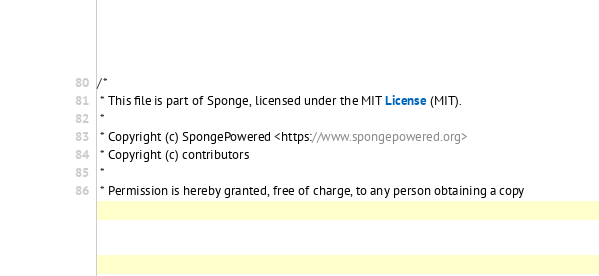<code> <loc_0><loc_0><loc_500><loc_500><_Java_>/*
 * This file is part of Sponge, licensed under the MIT License (MIT).
 *
 * Copyright (c) SpongePowered <https://www.spongepowered.org>
 * Copyright (c) contributors
 *
 * Permission is hereby granted, free of charge, to any person obtaining a copy</code> 